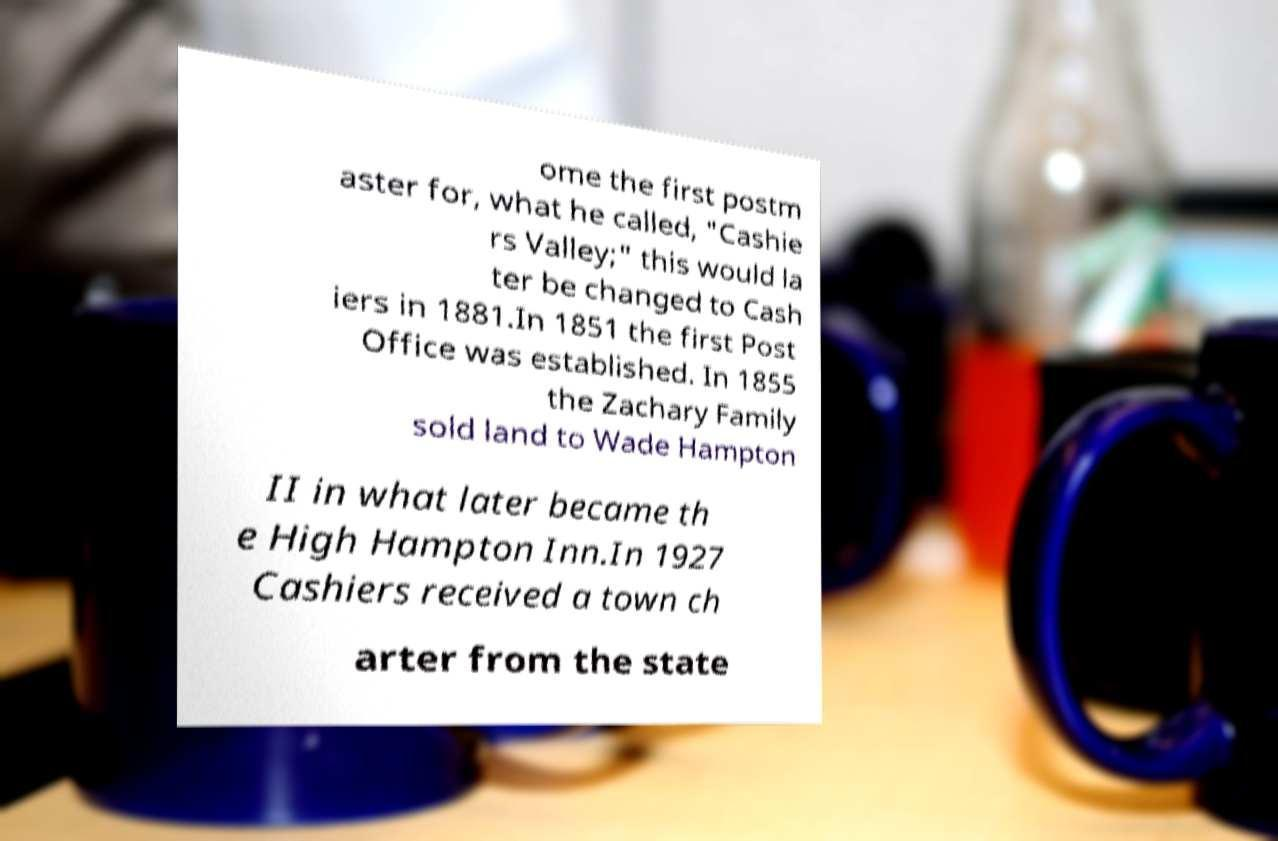Can you accurately transcribe the text from the provided image for me? ome the first postm aster for, what he called, "Cashie rs Valley;" this would la ter be changed to Cash iers in 1881.In 1851 the first Post Office was established. In 1855 the Zachary Family sold land to Wade Hampton II in what later became th e High Hampton Inn.In 1927 Cashiers received a town ch arter from the state 